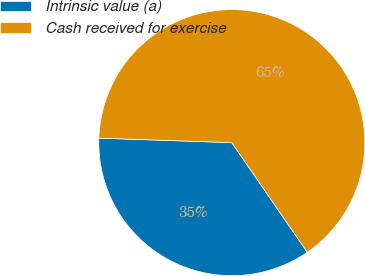Convert chart. <chart><loc_0><loc_0><loc_500><loc_500><pie_chart><fcel>Intrinsic value (a)<fcel>Cash received for exercise<nl><fcel>35.14%<fcel>64.86%<nl></chart> 